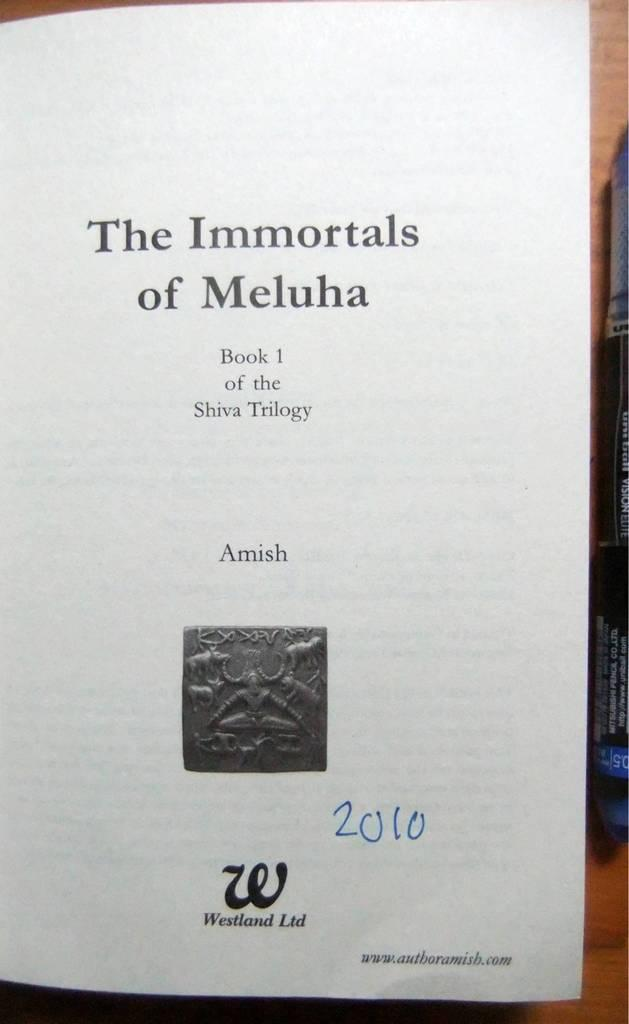<image>
Render a clear and concise summary of the photo. Booklet that is titled "The Immortals of Meluha". 